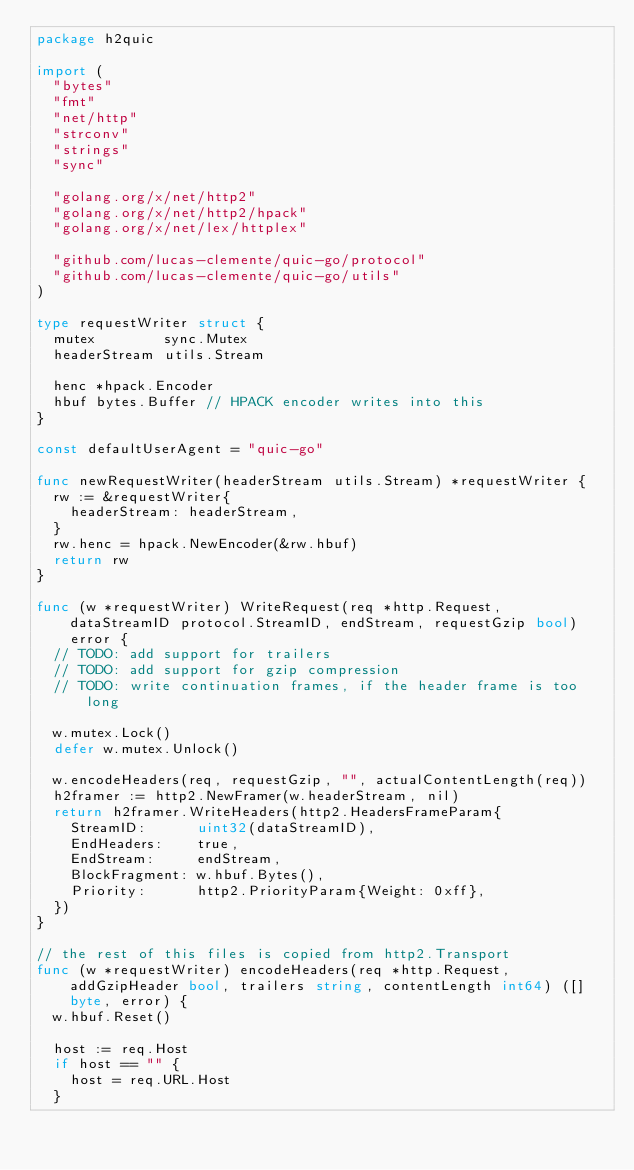Convert code to text. <code><loc_0><loc_0><loc_500><loc_500><_Go_>package h2quic

import (
	"bytes"
	"fmt"
	"net/http"
	"strconv"
	"strings"
	"sync"

	"golang.org/x/net/http2"
	"golang.org/x/net/http2/hpack"
	"golang.org/x/net/lex/httplex"

	"github.com/lucas-clemente/quic-go/protocol"
	"github.com/lucas-clemente/quic-go/utils"
)

type requestWriter struct {
	mutex        sync.Mutex
	headerStream utils.Stream

	henc *hpack.Encoder
	hbuf bytes.Buffer // HPACK encoder writes into this
}

const defaultUserAgent = "quic-go"

func newRequestWriter(headerStream utils.Stream) *requestWriter {
	rw := &requestWriter{
		headerStream: headerStream,
	}
	rw.henc = hpack.NewEncoder(&rw.hbuf)
	return rw
}

func (w *requestWriter) WriteRequest(req *http.Request, dataStreamID protocol.StreamID, endStream, requestGzip bool) error {
	// TODO: add support for trailers
	// TODO: add support for gzip compression
	// TODO: write continuation frames, if the header frame is too long

	w.mutex.Lock()
	defer w.mutex.Unlock()

	w.encodeHeaders(req, requestGzip, "", actualContentLength(req))
	h2framer := http2.NewFramer(w.headerStream, nil)
	return h2framer.WriteHeaders(http2.HeadersFrameParam{
		StreamID:      uint32(dataStreamID),
		EndHeaders:    true,
		EndStream:     endStream,
		BlockFragment: w.hbuf.Bytes(),
		Priority:      http2.PriorityParam{Weight: 0xff},
	})
}

// the rest of this files is copied from http2.Transport
func (w *requestWriter) encodeHeaders(req *http.Request, addGzipHeader bool, trailers string, contentLength int64) ([]byte, error) {
	w.hbuf.Reset()

	host := req.Host
	if host == "" {
		host = req.URL.Host
	}</code> 